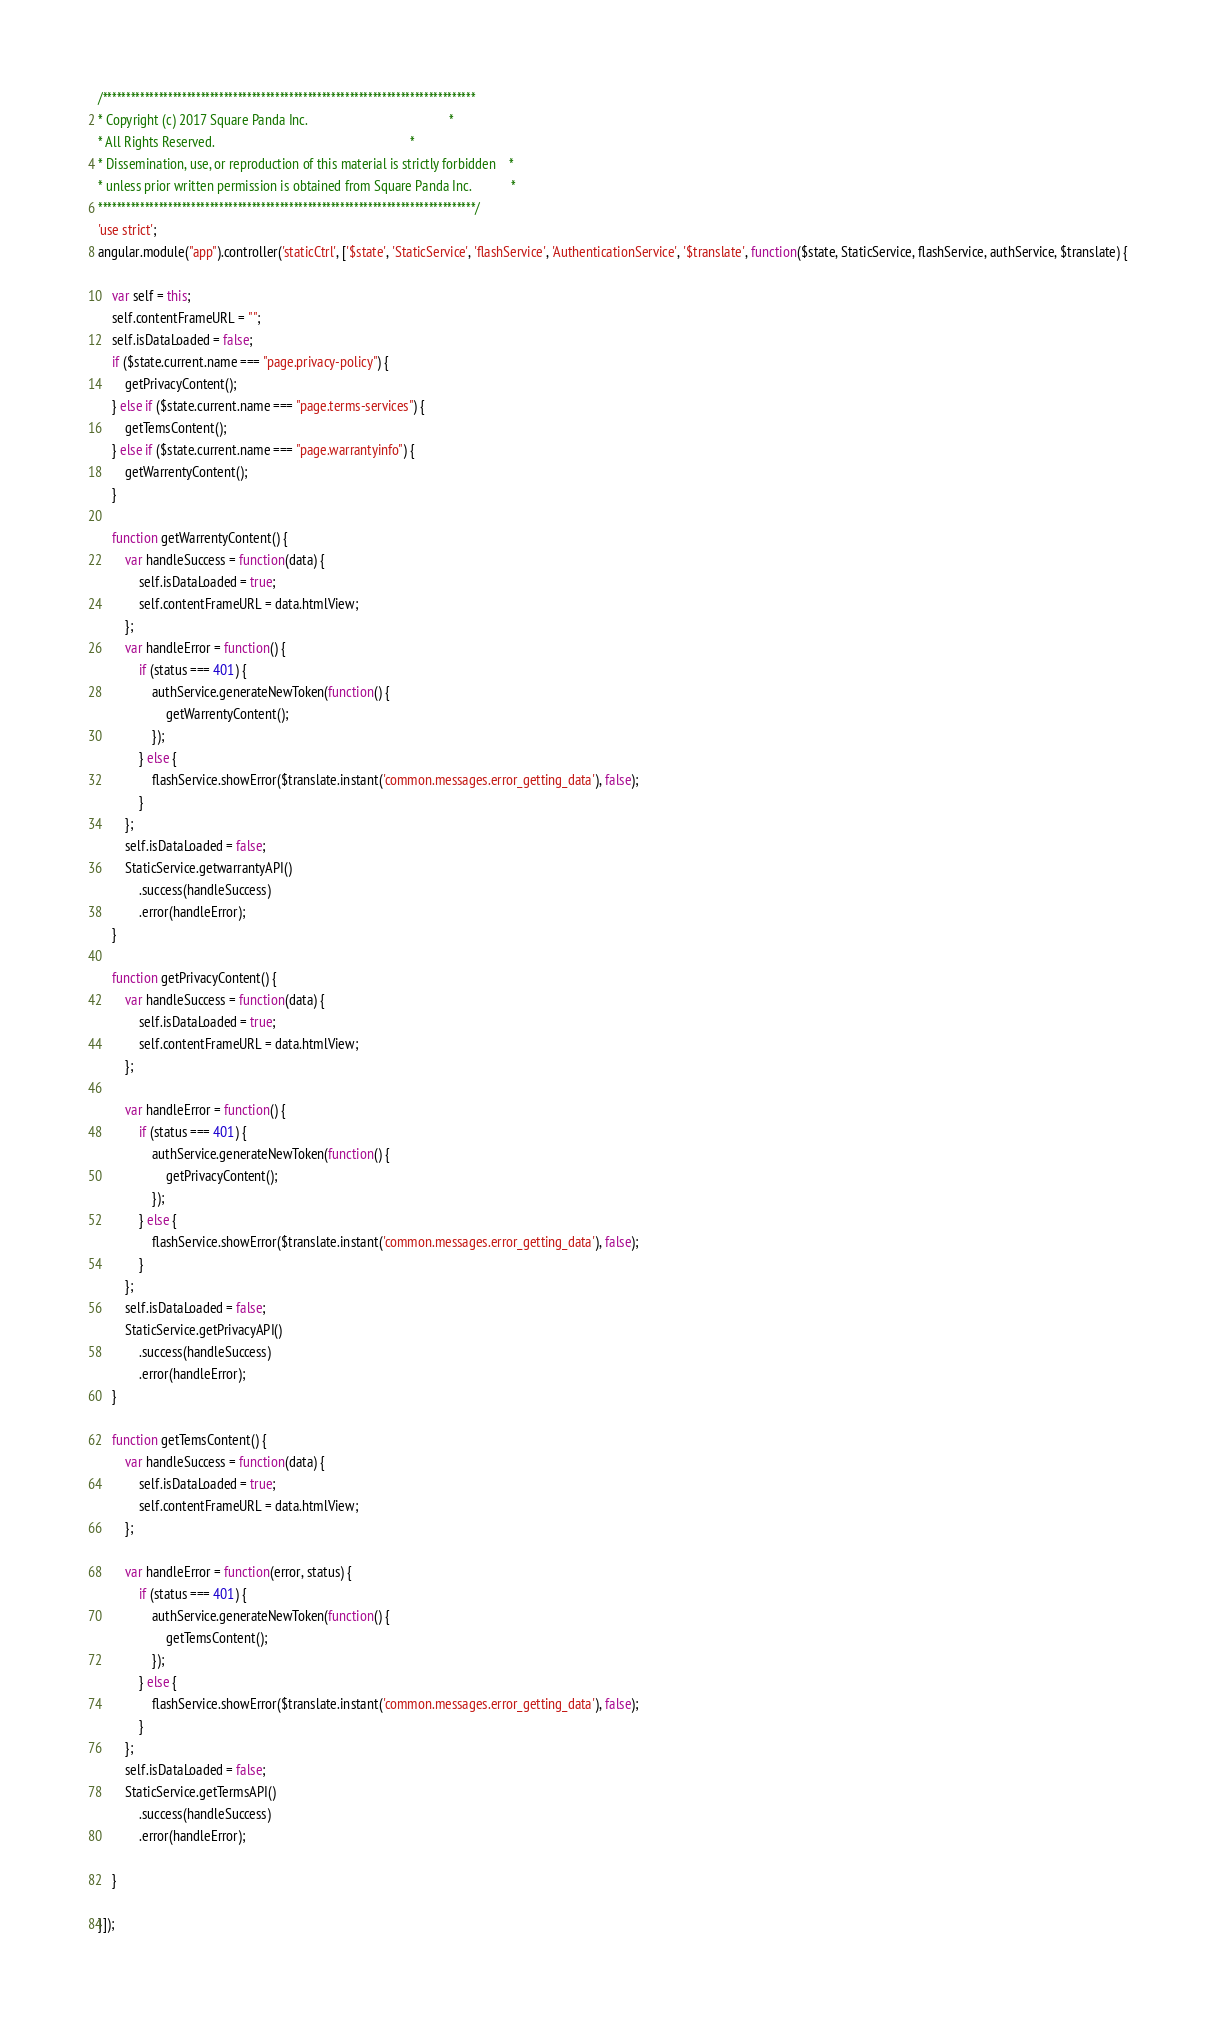<code> <loc_0><loc_0><loc_500><loc_500><_JavaScript_>/********************************************************************************
* Copyright (c) 2017 Square Panda Inc.                                          *
* All Rights Reserved.                                                          *
* Dissemination, use, or reproduction of this material is strictly forbidden    *
* unless prior written permission is obtained from Square Panda Inc.            *
*********************************************************************************/
'use strict';
angular.module("app").controller('staticCtrl', ['$state', 'StaticService', 'flashService', 'AuthenticationService', '$translate', function($state, StaticService, flashService, authService, $translate) {

    var self = this;
    self.contentFrameURL = "";
    self.isDataLoaded = false;
    if ($state.current.name === "page.privacy-policy") {
        getPrivacyContent();
    } else if ($state.current.name === "page.terms-services") {
        getTemsContent();
    } else if ($state.current.name === "page.warrantyinfo") {
        getWarrentyContent();
    }

    function getWarrentyContent() {
        var handleSuccess = function(data) {
            self.isDataLoaded = true;
            self.contentFrameURL = data.htmlView;
        };
        var handleError = function() {
            if (status === 401) {
                authService.generateNewToken(function() {
                    getWarrentyContent();
                });
            } else {
                flashService.showError($translate.instant('common.messages.error_getting_data'), false);
            }
        };
        self.isDataLoaded = false;
        StaticService.getwarrantyAPI()
            .success(handleSuccess)
            .error(handleError);
    }

    function getPrivacyContent() {
        var handleSuccess = function(data) {
            self.isDataLoaded = true;
            self.contentFrameURL = data.htmlView;
        };

        var handleError = function() {
            if (status === 401) {
                authService.generateNewToken(function() {
                    getPrivacyContent();
                });
            } else {
                flashService.showError($translate.instant('common.messages.error_getting_data'), false);
            }
        };
        self.isDataLoaded = false;
        StaticService.getPrivacyAPI()
            .success(handleSuccess)
            .error(handleError);
    }

    function getTemsContent() {
        var handleSuccess = function(data) {
            self.isDataLoaded = true;
            self.contentFrameURL = data.htmlView;
        };

        var handleError = function(error, status) {
            if (status === 401) {
                authService.generateNewToken(function() {
                    getTemsContent();
                });
            } else {
                flashService.showError($translate.instant('common.messages.error_getting_data'), false);
            }
        };
        self.isDataLoaded = false;
        StaticService.getTermsAPI()
            .success(handleSuccess)
            .error(handleError);

    }

}]);</code> 